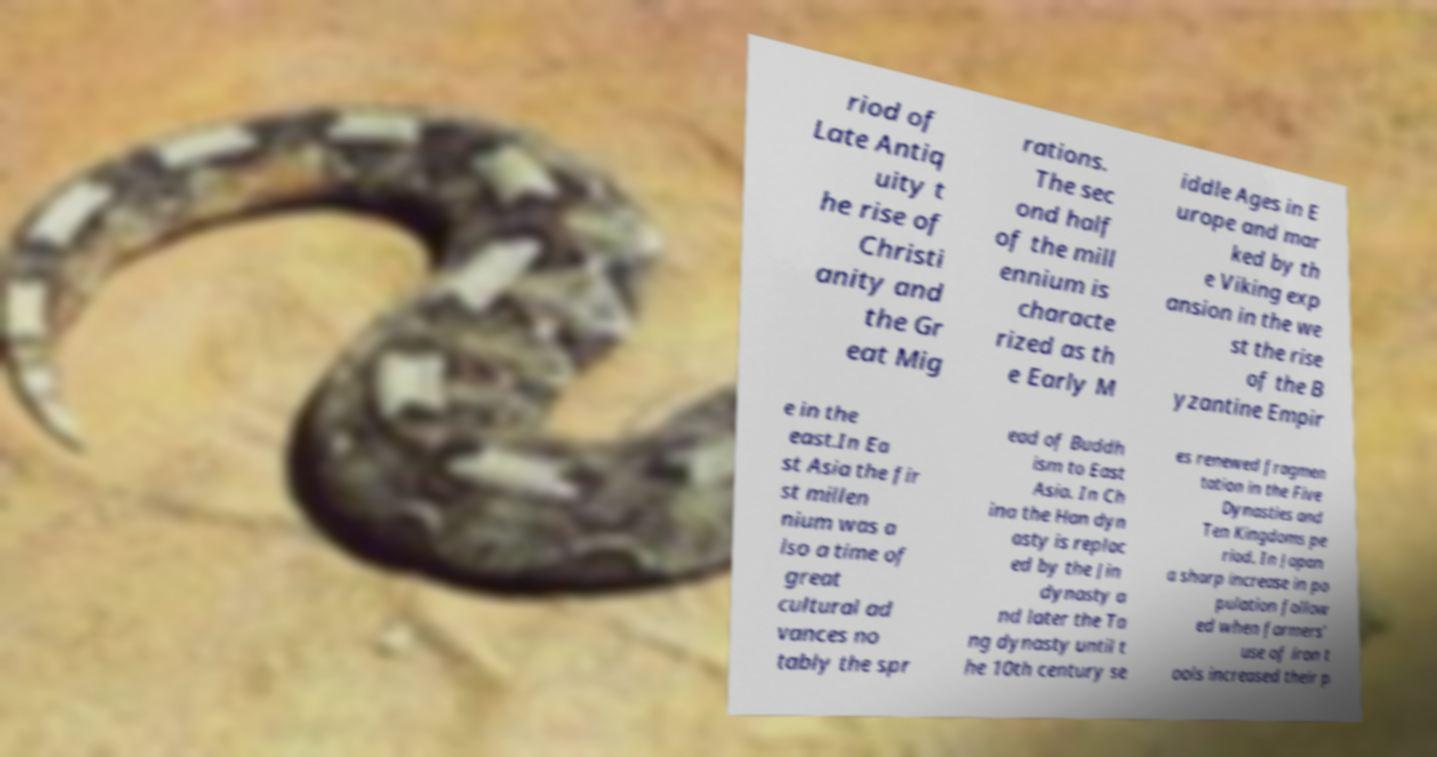Could you extract and type out the text from this image? riod of Late Antiq uity t he rise of Christi anity and the Gr eat Mig rations. The sec ond half of the mill ennium is characte rized as th e Early M iddle Ages in E urope and mar ked by th e Viking exp ansion in the we st the rise of the B yzantine Empir e in the east.In Ea st Asia the fir st millen nium was a lso a time of great cultural ad vances no tably the spr ead of Buddh ism to East Asia. In Ch ina the Han dyn asty is replac ed by the Jin dynasty a nd later the Ta ng dynasty until t he 10th century se es renewed fragmen tation in the Five Dynasties and Ten Kingdoms pe riod. In Japan a sharp increase in po pulation follow ed when farmers' use of iron t ools increased their p 